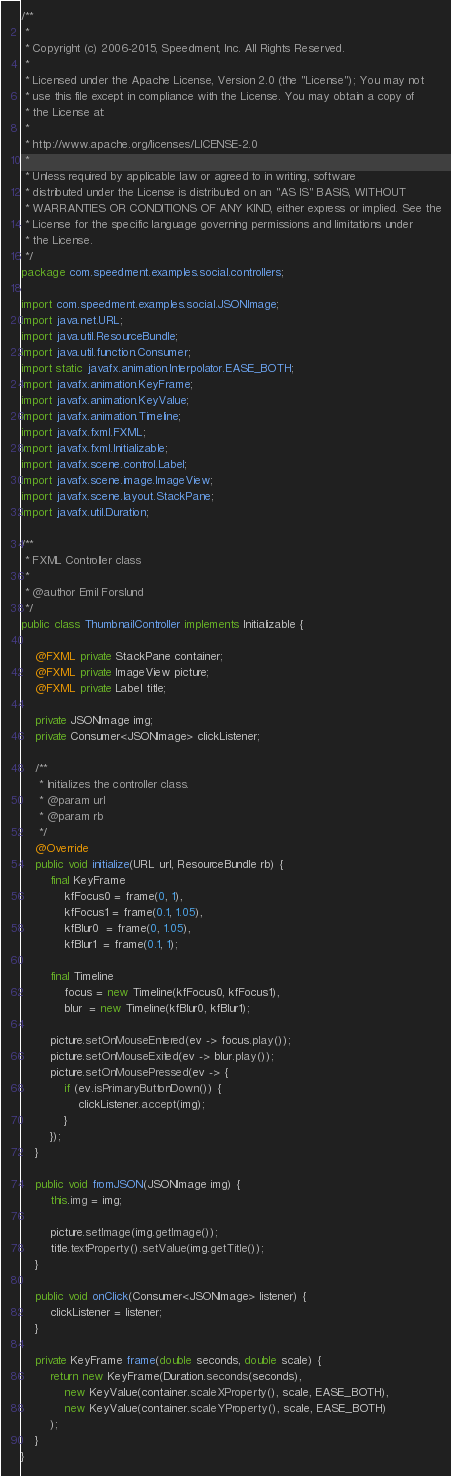<code> <loc_0><loc_0><loc_500><loc_500><_Java_>/**
 *
 * Copyright (c) 2006-2015, Speedment, Inc. All Rights Reserved.
 *
 * Licensed under the Apache License, Version 2.0 (the "License"); You may not
 * use this file except in compliance with the License. You may obtain a copy of
 * the License at:
 *
 * http://www.apache.org/licenses/LICENSE-2.0
 *
 * Unless required by applicable law or agreed to in writing, software
 * distributed under the License is distributed on an "AS IS" BASIS, WITHOUT
 * WARRANTIES OR CONDITIONS OF ANY KIND, either express or implied. See the
 * License for the specific language governing permissions and limitations under
 * the License.
 */
package com.speedment.examples.social.controllers;

import com.speedment.examples.social.JSONImage;
import java.net.URL;
import java.util.ResourceBundle;
import java.util.function.Consumer;
import static javafx.animation.Interpolator.EASE_BOTH;
import javafx.animation.KeyFrame;
import javafx.animation.KeyValue;
import javafx.animation.Timeline;
import javafx.fxml.FXML;
import javafx.fxml.Initializable;
import javafx.scene.control.Label;
import javafx.scene.image.ImageView;
import javafx.scene.layout.StackPane;
import javafx.util.Duration;

/**
 * FXML Controller class
 *
 * @author Emil Forslund
 */
public class ThumbnailController implements Initializable {
	
	@FXML private StackPane container;
	@FXML private ImageView picture;
	@FXML private Label title;

	private JSONImage img;
	private Consumer<JSONImage> clickListener;

	/**
	 * Initializes the controller class.
	 * @param url
	 * @param rb
	 */
	@Override
	public void initialize(URL url, ResourceBundle rb) {
		final KeyFrame 
			kfFocus0 = frame(0, 1),
			kfFocus1 = frame(0.1, 1.05),
			kfBlur0  = frame(0, 1.05),
			kfBlur1  = frame(0.1, 1);

		final Timeline 
			focus = new Timeline(kfFocus0, kfFocus1),
			blur  = new Timeline(kfBlur0, kfBlur1);

		picture.setOnMouseEntered(ev -> focus.play());
		picture.setOnMouseExited(ev -> blur.play());
		picture.setOnMousePressed(ev -> {
			if (ev.isPrimaryButtonDown()) {
				clickListener.accept(img);
			}
		});
	}
	
	public void fromJSON(JSONImage img) {
		this.img = img;
		
		picture.setImage(img.getImage());
		title.textProperty().setValue(img.getTitle());
	}
	
	public void onClick(Consumer<JSONImage> listener) {
		clickListener = listener;
	}
	
	private KeyFrame frame(double seconds, double scale) {
		return new KeyFrame(Duration.seconds(seconds),
			new KeyValue(container.scaleXProperty(), scale, EASE_BOTH),
			new KeyValue(container.scaleYProperty(), scale, EASE_BOTH)
		);
	}
}</code> 